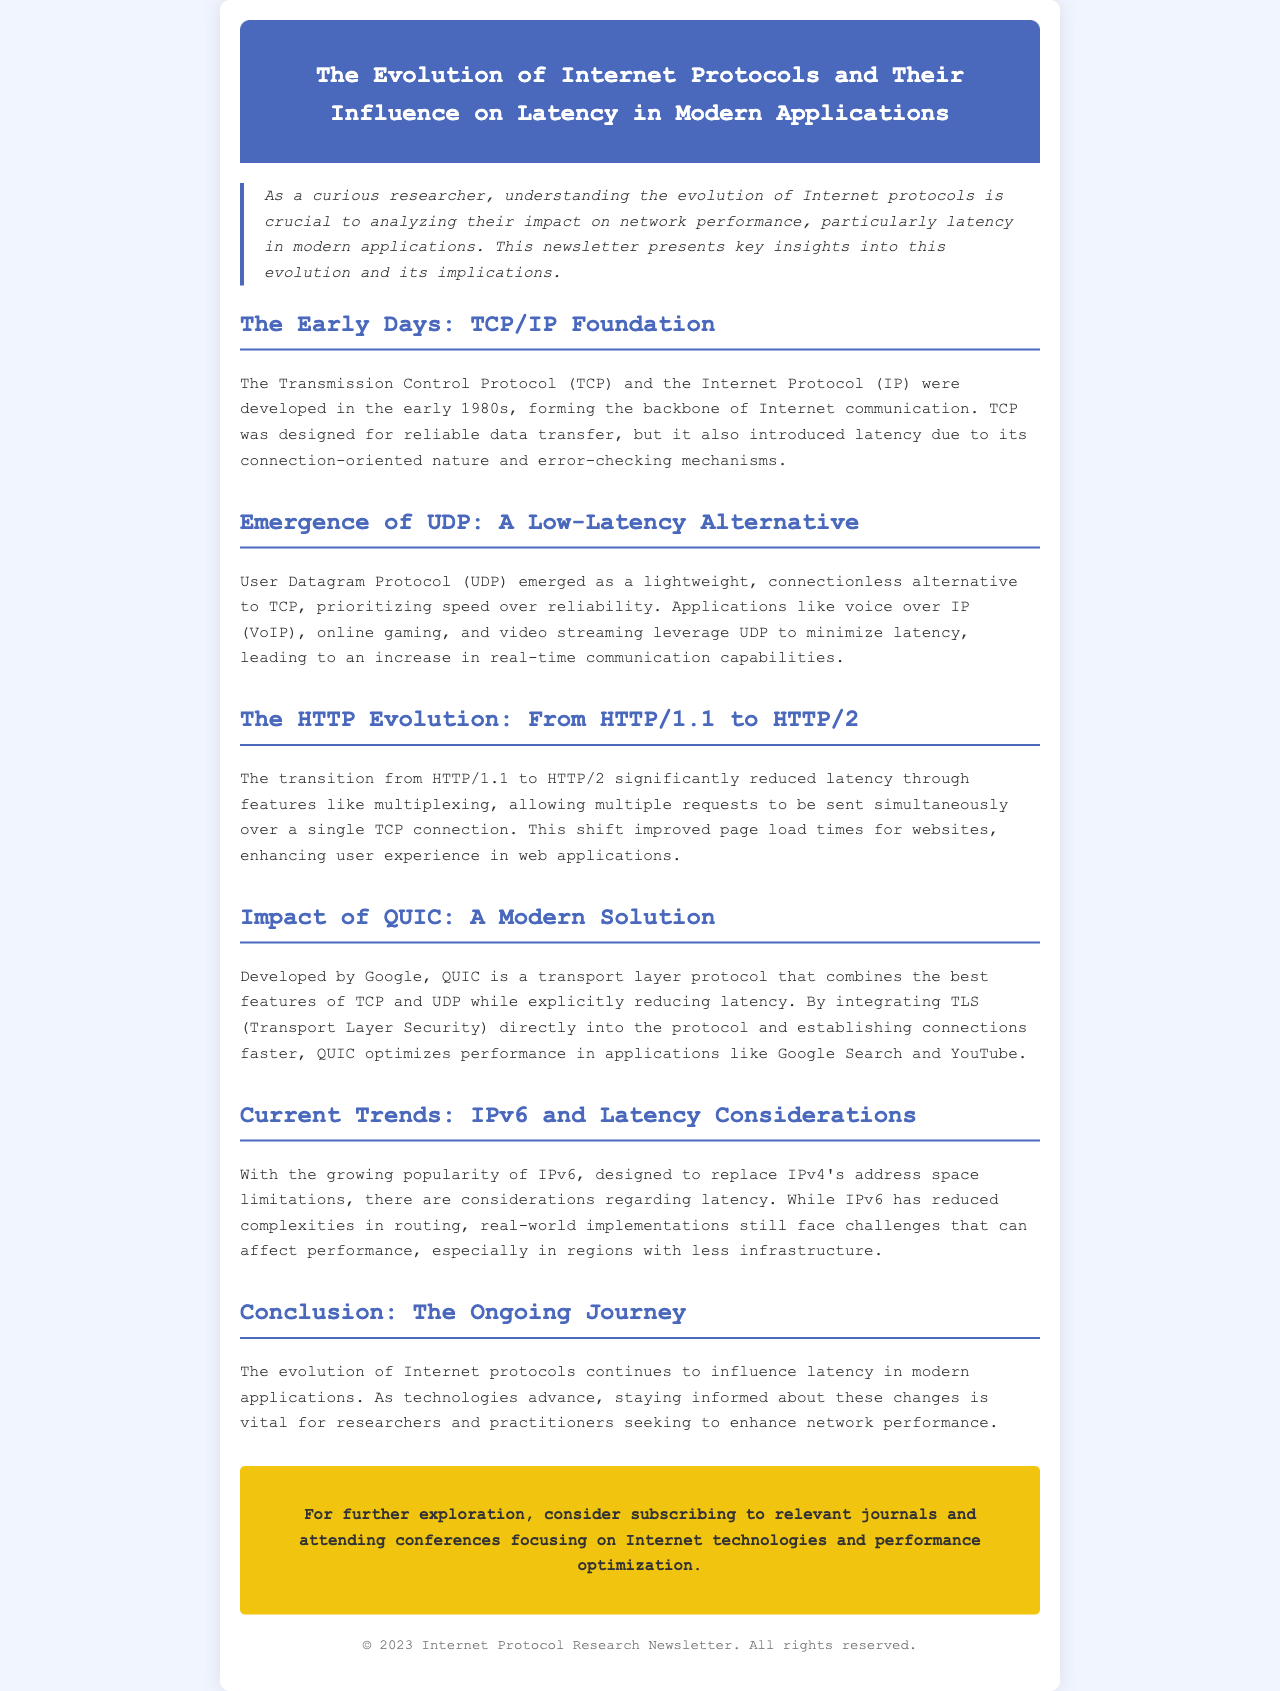What are the two key protocols developed in the early 1980s? The two key protocols developed in the early 1980s are the Transmission Control Protocol (TCP) and the Internet Protocol (IP).
Answer: TCP and IP What protocol prioritizes speed over reliability? The protocol that prioritizes speed over reliability is the User Datagram Protocol (UDP).
Answer: UDP Which version of HTTP introduced multiplexing? The version of HTTP that introduced multiplexing is HTTP/2.
Answer: HTTP/2 What modern solution combines features of TCP and UDP? The modern solution that combines features of TCP and UDP is QUIC.
Answer: QUIC What year is indicated in the copyright notice? The year indicated in the copyright notice is 2023.
Answer: 2023 How does IPv6 affect routing complexities? IPv6 has reduced complexities in routing.
Answer: Reduced What type of applications benefit from QUIC optimization? Applications like Google Search and YouTube benefit from QUIC optimization.
Answer: Google Search and YouTube What is the main topic of the newsletter? The main topic of the newsletter is the evolution of Internet protocols and their influence on latency in modern applications.
Answer: Evolution of Internet protocols and their influence on latency 